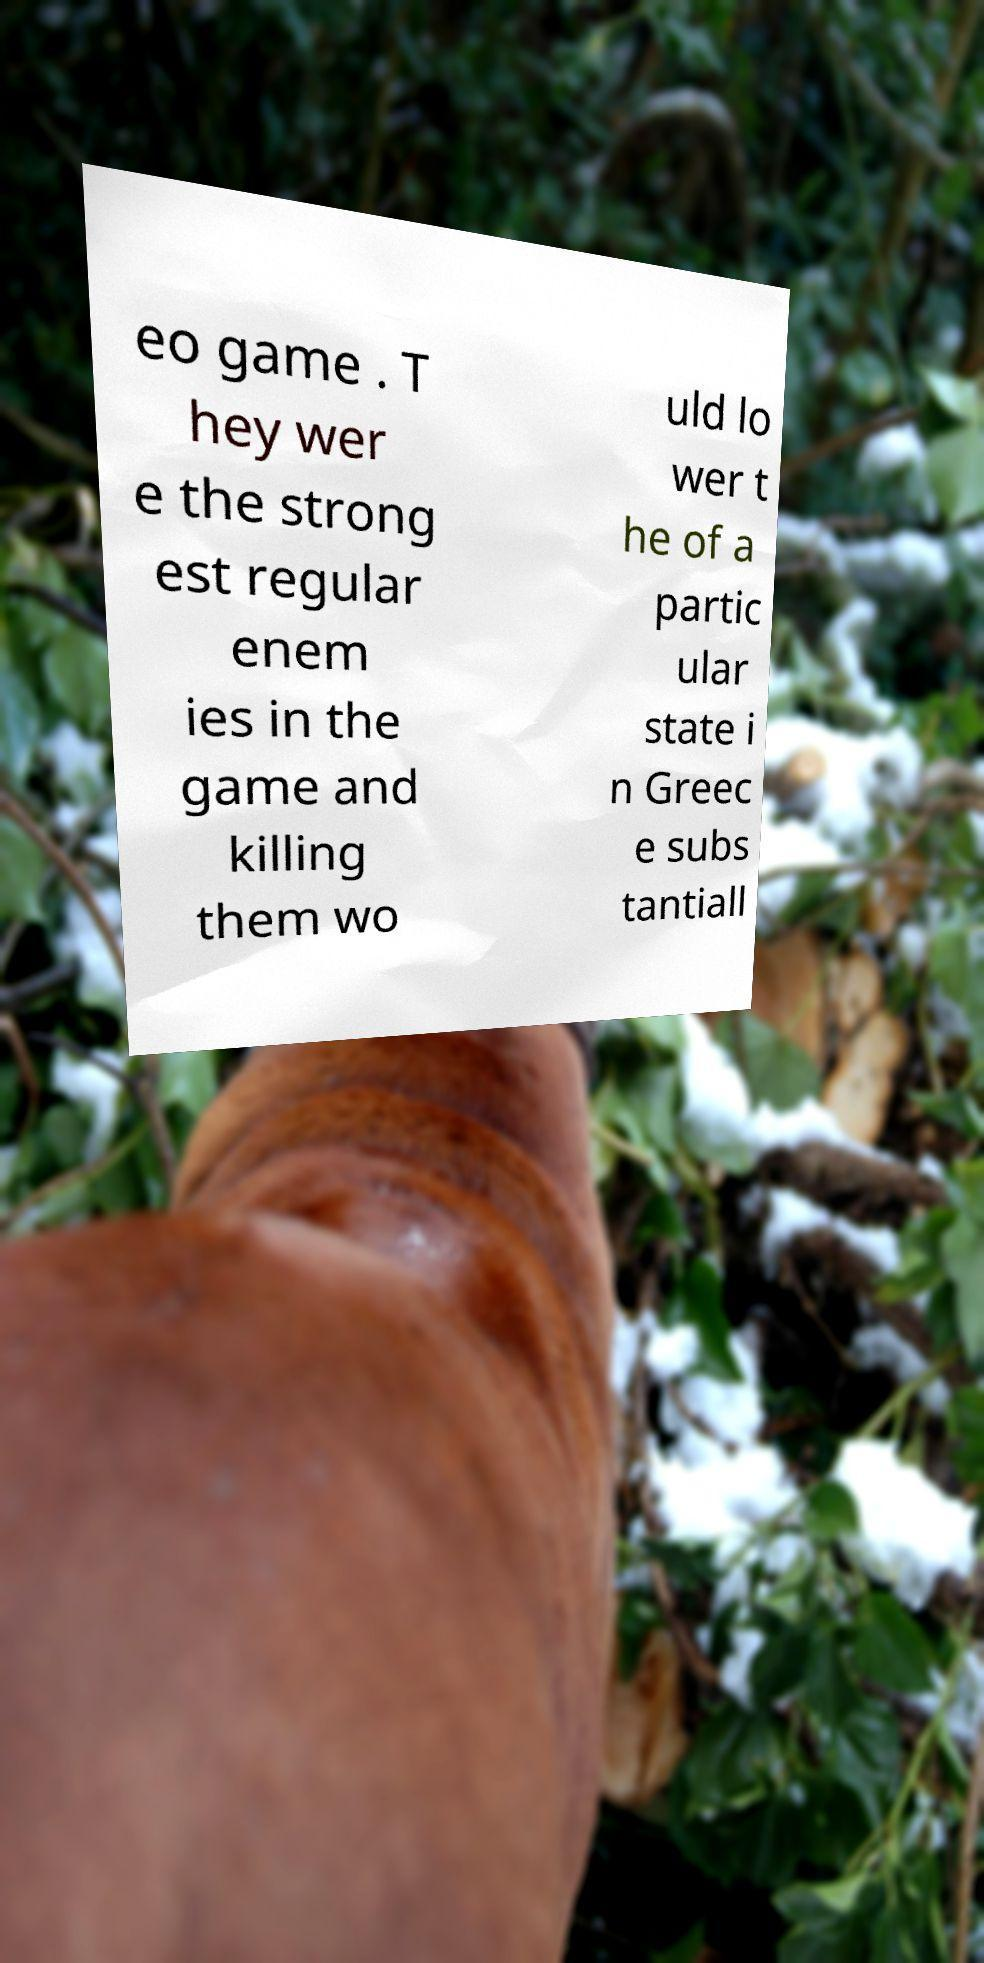I need the written content from this picture converted into text. Can you do that? eo game . T hey wer e the strong est regular enem ies in the game and killing them wo uld lo wer t he of a partic ular state i n Greec e subs tantiall 